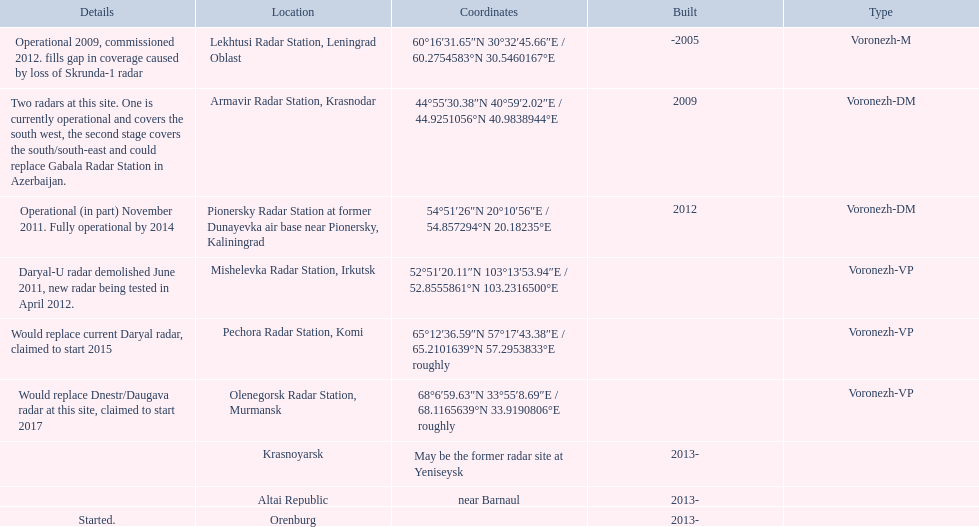Voronezh radar has locations where? Lekhtusi Radar Station, Leningrad Oblast, Armavir Radar Station, Krasnodar, Pionersky Radar Station at former Dunayevka air base near Pionersky, Kaliningrad, Mishelevka Radar Station, Irkutsk, Pechora Radar Station, Komi, Olenegorsk Radar Station, Murmansk, Krasnoyarsk, Altai Republic, Orenburg. Which of these locations have know coordinates? Lekhtusi Radar Station, Leningrad Oblast, Armavir Radar Station, Krasnodar, Pionersky Radar Station at former Dunayevka air base near Pionersky, Kaliningrad, Mishelevka Radar Station, Irkutsk, Pechora Radar Station, Komi, Olenegorsk Radar Station, Murmansk. Which of these locations has coordinates of 60deg16'31.65''n 30deg32'45.66''e / 60.2754583degn 30.5460167dege? Lekhtusi Radar Station, Leningrad Oblast. 